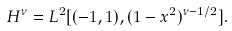Convert formula to latex. <formula><loc_0><loc_0><loc_500><loc_500>H ^ { \nu } = L ^ { 2 } [ ( - 1 , 1 ) , ( 1 - x ^ { 2 } ) ^ { \nu - 1 / 2 } ] .</formula> 